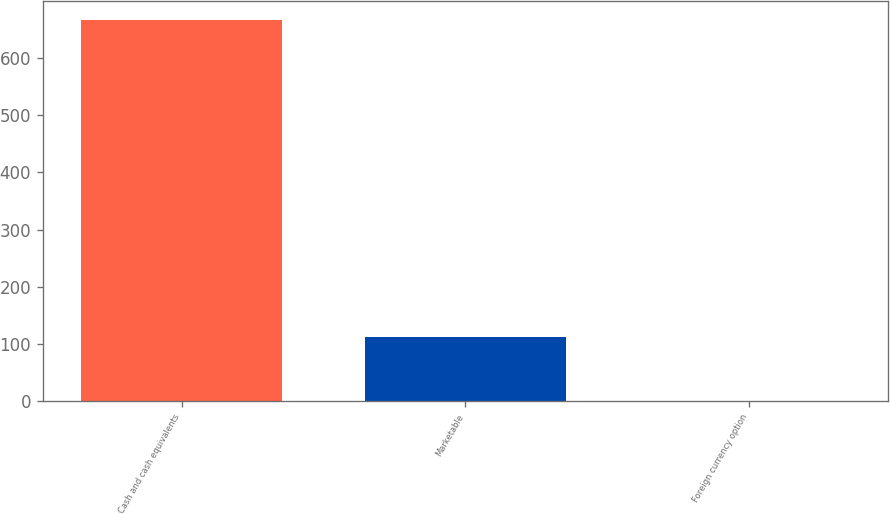Convert chart. <chart><loc_0><loc_0><loc_500><loc_500><bar_chart><fcel>Cash and cash equivalents<fcel>Marketable<fcel>Foreign currency option<nl><fcel>665.9<fcel>112<fcel>0.1<nl></chart> 